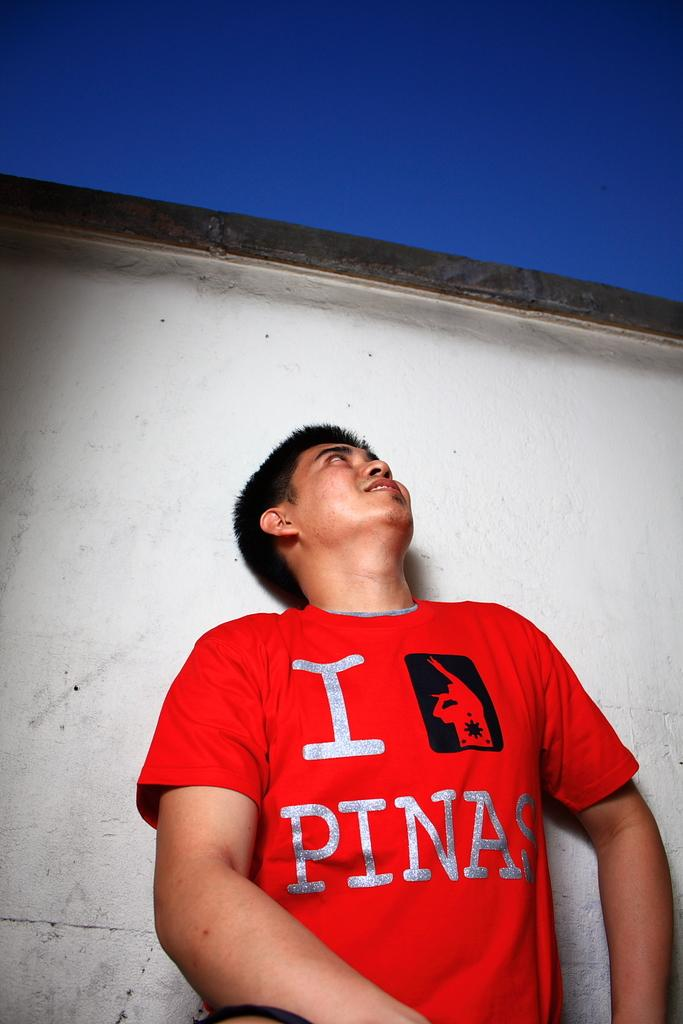What is the main subject of the image? There is a man standing in the image. What can be seen in the background of the image? There is a wall and the sky visible in the background of the image. What type of cheese is being exchanged at the faucet in the image? There is no cheese or faucet present in the image. 